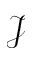Convert formula to latex. <formula><loc_0><loc_0><loc_500><loc_500>\mathcal { J }</formula> 